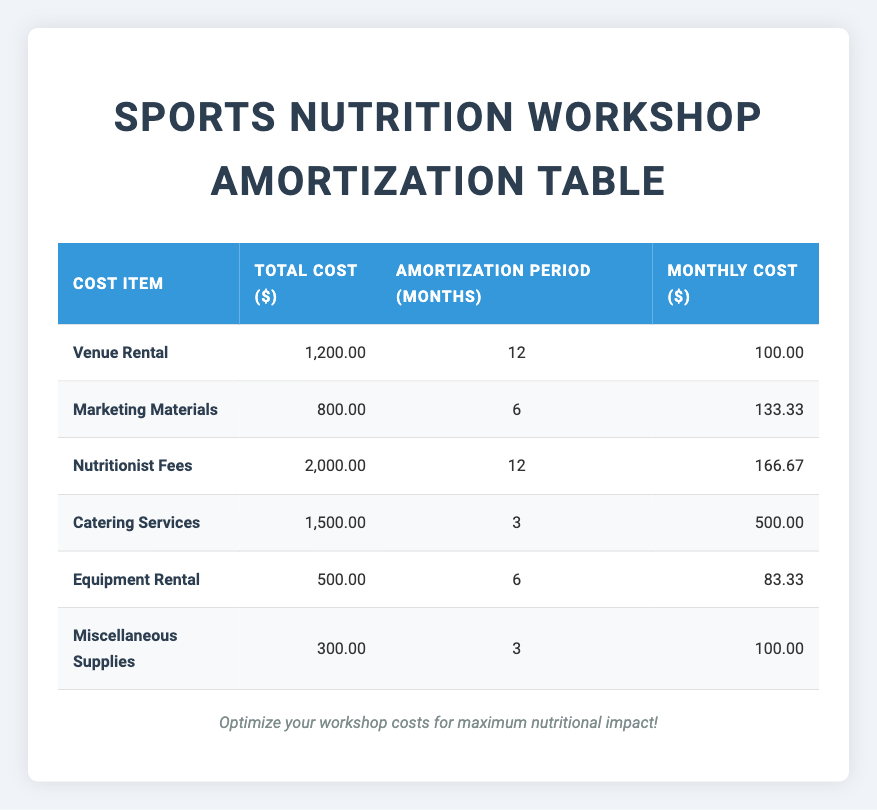What is the total cost for catering services? The table lists the cost for catering services as 1,500.00 in the "Total Cost ($)" column under "Catering Services."
Answer: 1,500.00 How long is the amortization period for equipment rental? The amortization period for equipment rental is displayed as 6 months in the "Amortization Period (Months)" column under "Equipment Rental."
Answer: 6 months What is the monthly cost for marketing materials? The monthly cost for marketing materials is calculated as 800.00 divided by the amortization period of 6 months, which equals 133.33. This value is shown in the "Monthly Cost ($)" column.
Answer: 133.33 If we sum the total costs of all items, what is the total? To find the sum, we add all total costs: 1200 + 800 + 2000 + 1500 + 500 + 300 = 5300. Thus, the total cost of all items is 5,300.
Answer: 5,300 Is the total cost for miscellaneous supplies more than 300? The table shows the total cost for miscellaneous supplies as 300, which means it is not greater than 300. Therefore, the answer is no.
Answer: No What is the difference between the monthly costs of catering services and nutritionist fees? The monthly cost of catering services is 500.00 and for nutritionist fees, it's 166.67. The difference is calculated as 500.00 - 166.67 = 333.33.
Answer: 333.33 Which cost item has the highest monthly cost, and what is that cost? After comparing the monthly costs listed, catering services at 500.00 is the highest. So, the highest cost item is catering services at 500.00.
Answer: Catering services, 500.00 How many cost items have amortization periods of 3 months? There are two cost items with an amortization period of 3 months, namely "Catering Services" and "Miscellaneous Supplies," as seen in the table.
Answer: 2 What is the average monthly cost across all cost items? To find the average monthly cost, we sum all monthly costs: 100 + 133.33 + 166.67 + 500 + 83.33 + 100 = 1,183.33. Then, we divide by the number of cost items, which is 6: 1,183.33 / 6 = 197.22. Therefore, the average monthly cost is approximately 197.22.
Answer: 197.22 